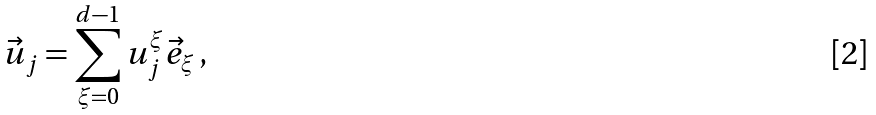<formula> <loc_0><loc_0><loc_500><loc_500>\vec { u } _ { j } = \sum _ { \xi = 0 } ^ { d - 1 } u _ { j } ^ { \xi } \vec { e } _ { \xi } \, ,</formula> 